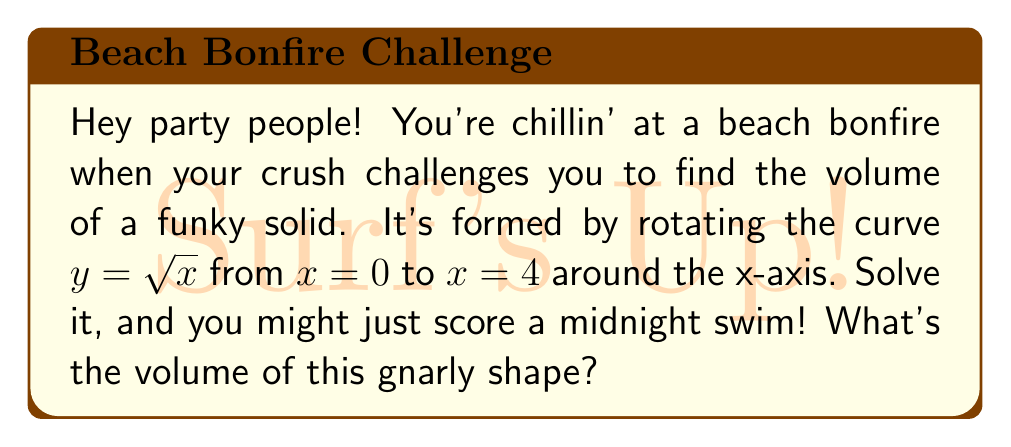Solve this math problem. Alright, let's tackle this without breaking a sweat:

1) We're dealing with a solid of revolution here, so we'll use the disk method. The formula for this is:

   $$V = \pi \int_a^b [f(x)]^2 dx$$

   Where $f(x)$ is our curve and we're integrating from $a$ to $b$.

2) In our case, $f(x) = \sqrt{x}$, $a = 0$, and $b = 4$. Let's plug that in:

   $$V = \pi \int_0^4 (\sqrt{x})^2 dx$$

3) Simplify the integrand:

   $$V = \pi \int_0^4 x dx$$

4) Now we integrate:

   $$V = \pi [\frac{1}{2}x^2]_0^4$$

5) Evaluate the integral:

   $$V = \pi [\frac{1}{2}(4^2) - \frac{1}{2}(0^2)]$$
   $$V = \pi [8 - 0]$$
   $$V = 8\pi$$

6) And that's it! The volume is $8\pi$ cubic units.
Answer: $8\pi$ cubic units 